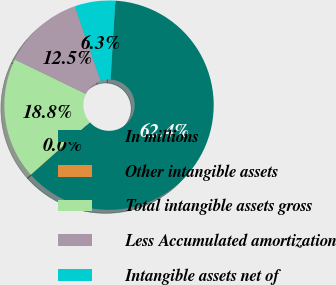Convert chart to OTSL. <chart><loc_0><loc_0><loc_500><loc_500><pie_chart><fcel>In millions<fcel>Other intangible assets<fcel>Total intangible assets gross<fcel>Less Accumulated amortization<fcel>Intangible assets net of<nl><fcel>62.43%<fcel>0.03%<fcel>18.75%<fcel>12.51%<fcel>6.27%<nl></chart> 